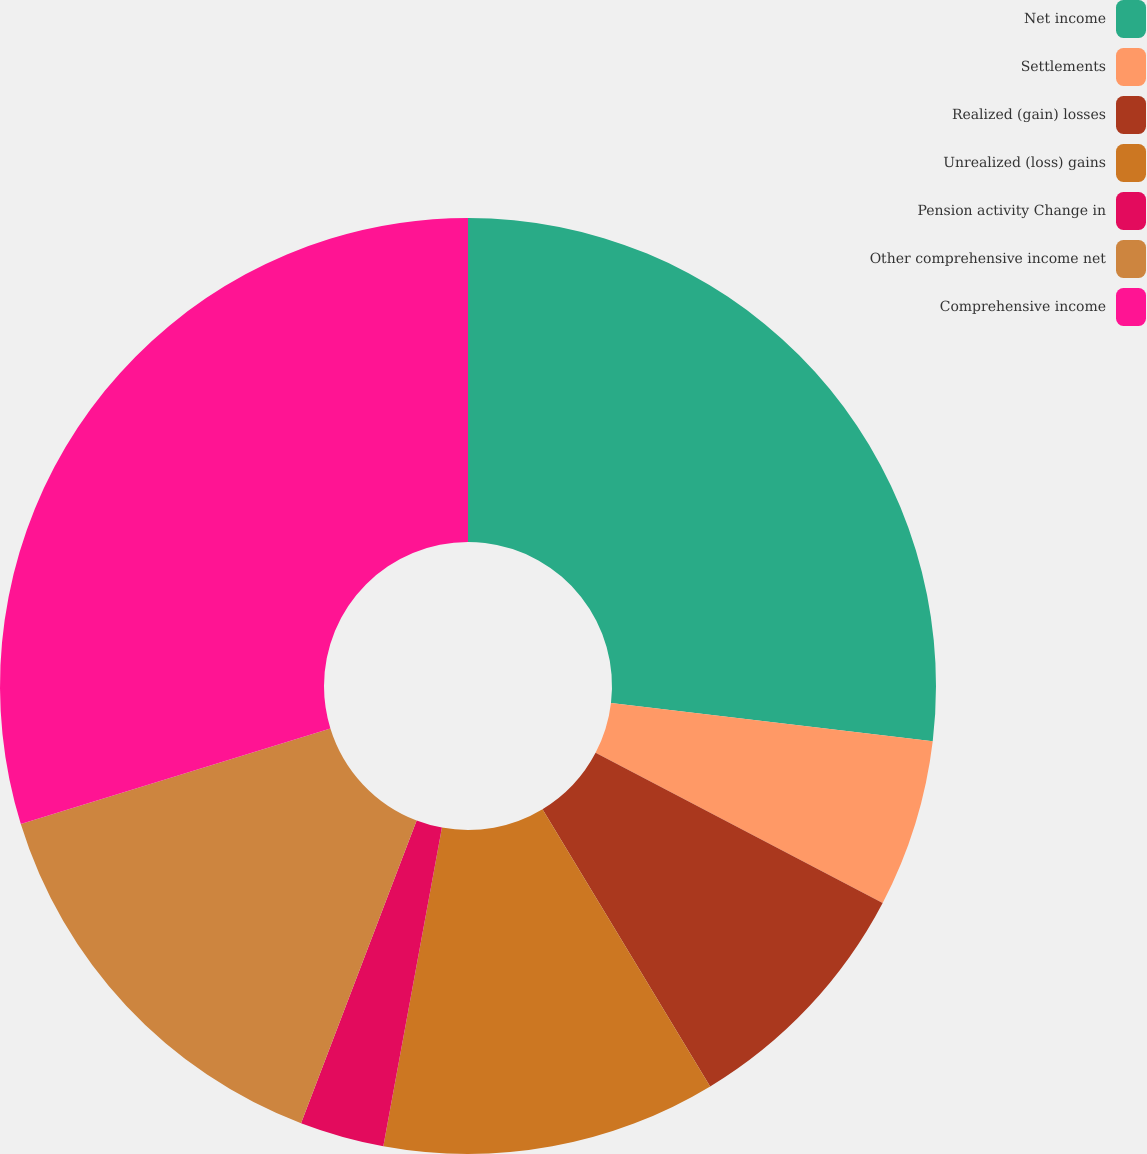<chart> <loc_0><loc_0><loc_500><loc_500><pie_chart><fcel>Net income<fcel>Settlements<fcel>Realized (gain) losses<fcel>Unrealized (loss) gains<fcel>Pension activity Change in<fcel>Other comprehensive income net<fcel>Comprehensive income<nl><fcel>26.88%<fcel>5.79%<fcel>8.67%<fcel>11.55%<fcel>2.91%<fcel>14.43%<fcel>29.76%<nl></chart> 